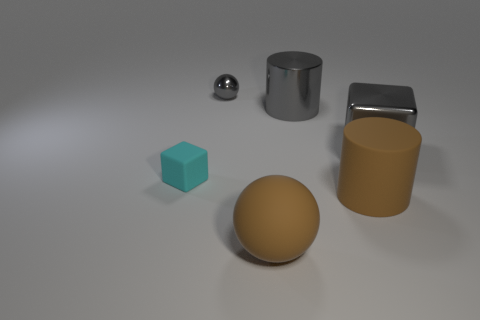Assuming they're in scale with each other, which object would be heaviest and why? If we assume all the objects are in scale with each other and they reflect the densities of their real-world materials, the upright cylindrical block, due to its larger volume and appearance of being made from a dense metal such as stainless steel, would likely be the heaviest. The sphere made of metal would come next, followed by the gold-toned sphere, the open-ended cylinder, and lastly, the small cube would be the lightest if it's made out of plastic. 